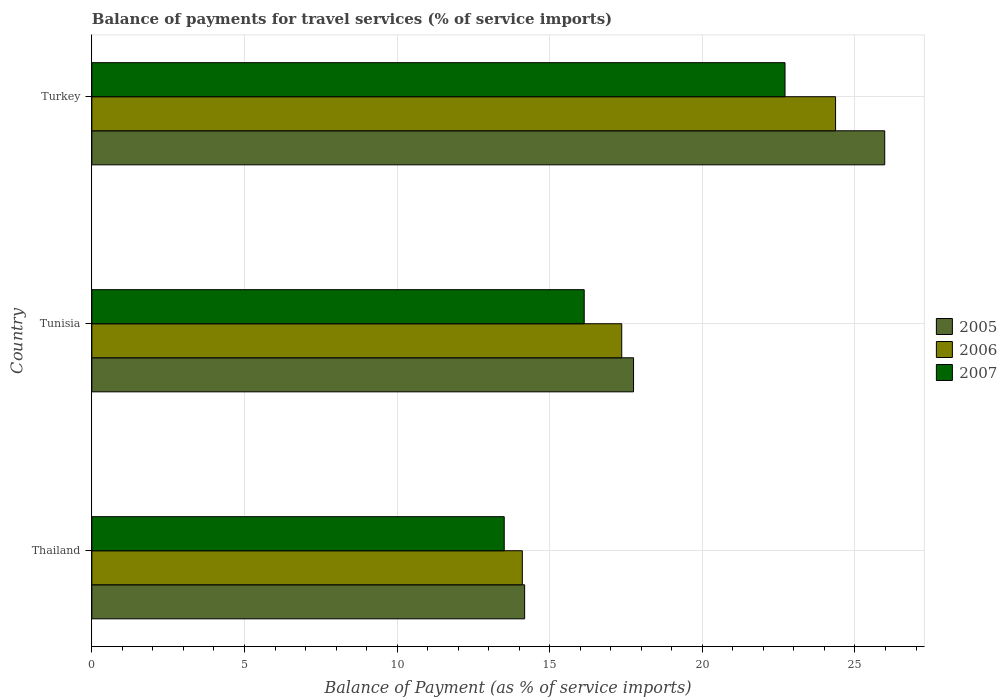How many groups of bars are there?
Provide a succinct answer. 3. Are the number of bars on each tick of the Y-axis equal?
Provide a succinct answer. Yes. How many bars are there on the 1st tick from the top?
Give a very brief answer. 3. What is the label of the 3rd group of bars from the top?
Your answer should be compact. Thailand. What is the balance of payments for travel services in 2005 in Tunisia?
Make the answer very short. 17.75. Across all countries, what is the maximum balance of payments for travel services in 2006?
Provide a succinct answer. 24.36. Across all countries, what is the minimum balance of payments for travel services in 2006?
Provide a succinct answer. 14.1. In which country was the balance of payments for travel services in 2005 minimum?
Make the answer very short. Thailand. What is the total balance of payments for travel services in 2007 in the graph?
Provide a short and direct response. 52.35. What is the difference between the balance of payments for travel services in 2007 in Thailand and that in Turkey?
Your answer should be compact. -9.2. What is the difference between the balance of payments for travel services in 2006 in Tunisia and the balance of payments for travel services in 2007 in Turkey?
Your answer should be very brief. -5.35. What is the average balance of payments for travel services in 2005 per country?
Provide a succinct answer. 19.3. What is the difference between the balance of payments for travel services in 2007 and balance of payments for travel services in 2005 in Tunisia?
Ensure brevity in your answer.  -1.62. What is the ratio of the balance of payments for travel services in 2006 in Thailand to that in Tunisia?
Your answer should be compact. 0.81. Is the difference between the balance of payments for travel services in 2007 in Thailand and Turkey greater than the difference between the balance of payments for travel services in 2005 in Thailand and Turkey?
Make the answer very short. Yes. What is the difference between the highest and the second highest balance of payments for travel services in 2005?
Your response must be concise. 8.23. What is the difference between the highest and the lowest balance of payments for travel services in 2007?
Ensure brevity in your answer.  9.2. In how many countries, is the balance of payments for travel services in 2007 greater than the average balance of payments for travel services in 2007 taken over all countries?
Offer a terse response. 1. Is the sum of the balance of payments for travel services in 2005 in Thailand and Turkey greater than the maximum balance of payments for travel services in 2006 across all countries?
Offer a very short reply. Yes. Is it the case that in every country, the sum of the balance of payments for travel services in 2005 and balance of payments for travel services in 2007 is greater than the balance of payments for travel services in 2006?
Keep it short and to the point. Yes. How many countries are there in the graph?
Keep it short and to the point. 3. Does the graph contain any zero values?
Make the answer very short. No. Where does the legend appear in the graph?
Your response must be concise. Center right. How many legend labels are there?
Your answer should be compact. 3. What is the title of the graph?
Your response must be concise. Balance of payments for travel services (% of service imports). Does "2006" appear as one of the legend labels in the graph?
Keep it short and to the point. Yes. What is the label or title of the X-axis?
Give a very brief answer. Balance of Payment (as % of service imports). What is the Balance of Payment (as % of service imports) of 2005 in Thailand?
Provide a short and direct response. 14.18. What is the Balance of Payment (as % of service imports) of 2006 in Thailand?
Your response must be concise. 14.1. What is the Balance of Payment (as % of service imports) in 2007 in Thailand?
Your response must be concise. 13.51. What is the Balance of Payment (as % of service imports) of 2005 in Tunisia?
Your answer should be compact. 17.75. What is the Balance of Payment (as % of service imports) of 2006 in Tunisia?
Your answer should be compact. 17.36. What is the Balance of Payment (as % of service imports) in 2007 in Tunisia?
Provide a short and direct response. 16.13. What is the Balance of Payment (as % of service imports) of 2005 in Turkey?
Offer a terse response. 25.97. What is the Balance of Payment (as % of service imports) of 2006 in Turkey?
Make the answer very short. 24.36. What is the Balance of Payment (as % of service imports) in 2007 in Turkey?
Ensure brevity in your answer.  22.71. Across all countries, what is the maximum Balance of Payment (as % of service imports) in 2005?
Your response must be concise. 25.97. Across all countries, what is the maximum Balance of Payment (as % of service imports) in 2006?
Your response must be concise. 24.36. Across all countries, what is the maximum Balance of Payment (as % of service imports) in 2007?
Keep it short and to the point. 22.71. Across all countries, what is the minimum Balance of Payment (as % of service imports) of 2005?
Make the answer very short. 14.18. Across all countries, what is the minimum Balance of Payment (as % of service imports) in 2006?
Keep it short and to the point. 14.1. Across all countries, what is the minimum Balance of Payment (as % of service imports) of 2007?
Give a very brief answer. 13.51. What is the total Balance of Payment (as % of service imports) in 2005 in the graph?
Your answer should be compact. 57.9. What is the total Balance of Payment (as % of service imports) of 2006 in the graph?
Offer a terse response. 55.83. What is the total Balance of Payment (as % of service imports) of 2007 in the graph?
Make the answer very short. 52.35. What is the difference between the Balance of Payment (as % of service imports) of 2005 in Thailand and that in Tunisia?
Ensure brevity in your answer.  -3.57. What is the difference between the Balance of Payment (as % of service imports) of 2006 in Thailand and that in Tunisia?
Give a very brief answer. -3.26. What is the difference between the Balance of Payment (as % of service imports) in 2007 in Thailand and that in Tunisia?
Give a very brief answer. -2.62. What is the difference between the Balance of Payment (as % of service imports) of 2005 in Thailand and that in Turkey?
Provide a succinct answer. -11.8. What is the difference between the Balance of Payment (as % of service imports) of 2006 in Thailand and that in Turkey?
Offer a very short reply. -10.26. What is the difference between the Balance of Payment (as % of service imports) in 2007 in Thailand and that in Turkey?
Offer a very short reply. -9.2. What is the difference between the Balance of Payment (as % of service imports) of 2005 in Tunisia and that in Turkey?
Your response must be concise. -8.23. What is the difference between the Balance of Payment (as % of service imports) in 2006 in Tunisia and that in Turkey?
Your answer should be compact. -7.01. What is the difference between the Balance of Payment (as % of service imports) in 2007 in Tunisia and that in Turkey?
Your answer should be compact. -6.58. What is the difference between the Balance of Payment (as % of service imports) in 2005 in Thailand and the Balance of Payment (as % of service imports) in 2006 in Tunisia?
Keep it short and to the point. -3.18. What is the difference between the Balance of Payment (as % of service imports) of 2005 in Thailand and the Balance of Payment (as % of service imports) of 2007 in Tunisia?
Provide a short and direct response. -1.95. What is the difference between the Balance of Payment (as % of service imports) in 2006 in Thailand and the Balance of Payment (as % of service imports) in 2007 in Tunisia?
Ensure brevity in your answer.  -2.03. What is the difference between the Balance of Payment (as % of service imports) in 2005 in Thailand and the Balance of Payment (as % of service imports) in 2006 in Turkey?
Make the answer very short. -10.19. What is the difference between the Balance of Payment (as % of service imports) of 2005 in Thailand and the Balance of Payment (as % of service imports) of 2007 in Turkey?
Your answer should be very brief. -8.53. What is the difference between the Balance of Payment (as % of service imports) of 2006 in Thailand and the Balance of Payment (as % of service imports) of 2007 in Turkey?
Provide a succinct answer. -8.61. What is the difference between the Balance of Payment (as % of service imports) in 2005 in Tunisia and the Balance of Payment (as % of service imports) in 2006 in Turkey?
Provide a succinct answer. -6.62. What is the difference between the Balance of Payment (as % of service imports) of 2005 in Tunisia and the Balance of Payment (as % of service imports) of 2007 in Turkey?
Provide a short and direct response. -4.96. What is the difference between the Balance of Payment (as % of service imports) in 2006 in Tunisia and the Balance of Payment (as % of service imports) in 2007 in Turkey?
Offer a terse response. -5.35. What is the average Balance of Payment (as % of service imports) in 2005 per country?
Provide a succinct answer. 19.3. What is the average Balance of Payment (as % of service imports) in 2006 per country?
Ensure brevity in your answer.  18.61. What is the average Balance of Payment (as % of service imports) in 2007 per country?
Offer a terse response. 17.45. What is the difference between the Balance of Payment (as % of service imports) in 2005 and Balance of Payment (as % of service imports) in 2006 in Thailand?
Your answer should be compact. 0.08. What is the difference between the Balance of Payment (as % of service imports) of 2005 and Balance of Payment (as % of service imports) of 2007 in Thailand?
Your answer should be compact. 0.67. What is the difference between the Balance of Payment (as % of service imports) in 2006 and Balance of Payment (as % of service imports) in 2007 in Thailand?
Provide a succinct answer. 0.59. What is the difference between the Balance of Payment (as % of service imports) of 2005 and Balance of Payment (as % of service imports) of 2006 in Tunisia?
Offer a terse response. 0.39. What is the difference between the Balance of Payment (as % of service imports) of 2005 and Balance of Payment (as % of service imports) of 2007 in Tunisia?
Your response must be concise. 1.62. What is the difference between the Balance of Payment (as % of service imports) of 2006 and Balance of Payment (as % of service imports) of 2007 in Tunisia?
Provide a succinct answer. 1.23. What is the difference between the Balance of Payment (as % of service imports) of 2005 and Balance of Payment (as % of service imports) of 2006 in Turkey?
Give a very brief answer. 1.61. What is the difference between the Balance of Payment (as % of service imports) of 2005 and Balance of Payment (as % of service imports) of 2007 in Turkey?
Provide a short and direct response. 3.27. What is the difference between the Balance of Payment (as % of service imports) in 2006 and Balance of Payment (as % of service imports) in 2007 in Turkey?
Ensure brevity in your answer.  1.66. What is the ratio of the Balance of Payment (as % of service imports) of 2005 in Thailand to that in Tunisia?
Keep it short and to the point. 0.8. What is the ratio of the Balance of Payment (as % of service imports) in 2006 in Thailand to that in Tunisia?
Make the answer very short. 0.81. What is the ratio of the Balance of Payment (as % of service imports) of 2007 in Thailand to that in Tunisia?
Your response must be concise. 0.84. What is the ratio of the Balance of Payment (as % of service imports) of 2005 in Thailand to that in Turkey?
Keep it short and to the point. 0.55. What is the ratio of the Balance of Payment (as % of service imports) in 2006 in Thailand to that in Turkey?
Make the answer very short. 0.58. What is the ratio of the Balance of Payment (as % of service imports) of 2007 in Thailand to that in Turkey?
Offer a terse response. 0.59. What is the ratio of the Balance of Payment (as % of service imports) in 2005 in Tunisia to that in Turkey?
Offer a very short reply. 0.68. What is the ratio of the Balance of Payment (as % of service imports) of 2006 in Tunisia to that in Turkey?
Offer a terse response. 0.71. What is the ratio of the Balance of Payment (as % of service imports) in 2007 in Tunisia to that in Turkey?
Provide a short and direct response. 0.71. What is the difference between the highest and the second highest Balance of Payment (as % of service imports) in 2005?
Your answer should be very brief. 8.23. What is the difference between the highest and the second highest Balance of Payment (as % of service imports) of 2006?
Keep it short and to the point. 7.01. What is the difference between the highest and the second highest Balance of Payment (as % of service imports) of 2007?
Keep it short and to the point. 6.58. What is the difference between the highest and the lowest Balance of Payment (as % of service imports) in 2005?
Give a very brief answer. 11.8. What is the difference between the highest and the lowest Balance of Payment (as % of service imports) of 2006?
Provide a short and direct response. 10.26. What is the difference between the highest and the lowest Balance of Payment (as % of service imports) in 2007?
Your answer should be compact. 9.2. 